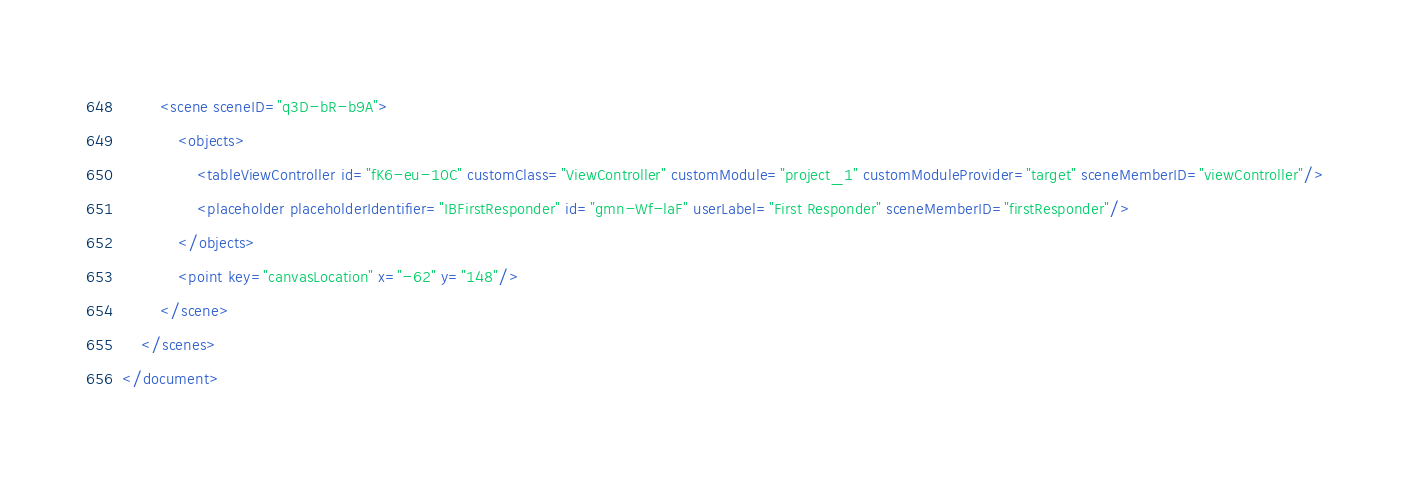Convert code to text. <code><loc_0><loc_0><loc_500><loc_500><_XML_>        <scene sceneID="q3D-bR-b9A">
            <objects>
                <tableViewController id="fK6-eu-10C" customClass="ViewController" customModule="project_1" customModuleProvider="target" sceneMemberID="viewController"/>
                <placeholder placeholderIdentifier="IBFirstResponder" id="gmn-Wf-laF" userLabel="First Responder" sceneMemberID="firstResponder"/>
            </objects>
            <point key="canvasLocation" x="-62" y="148"/>
        </scene>
    </scenes>
</document>
</code> 